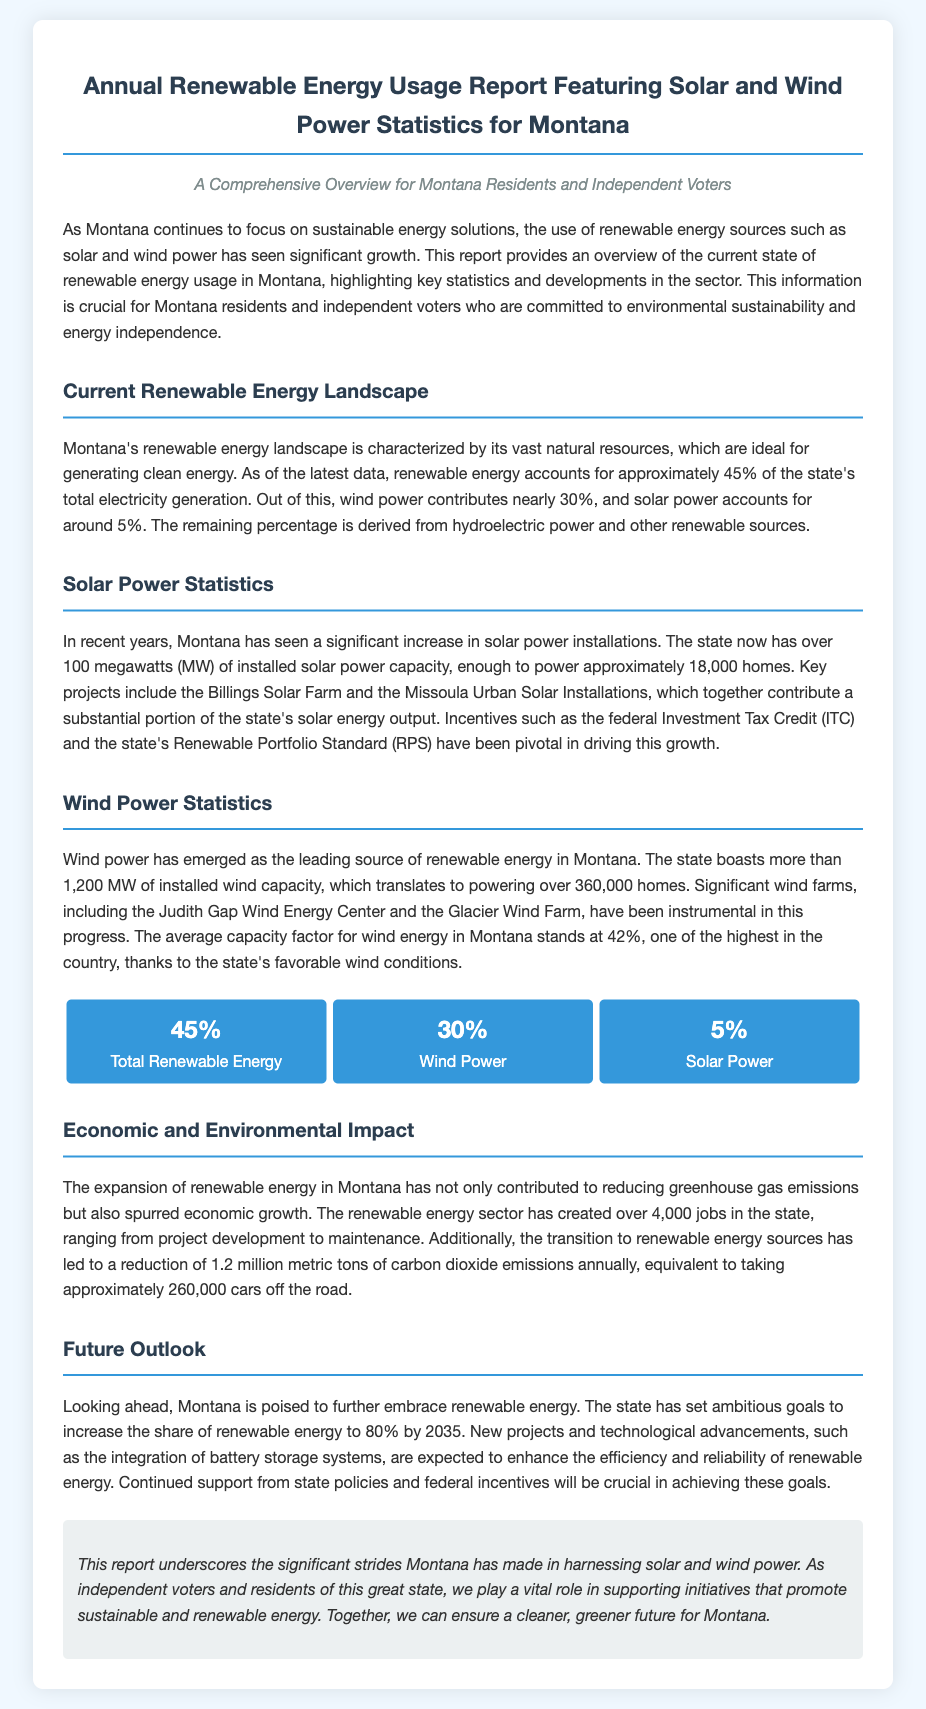what percentage of Montana's total electricity generation comes from renewable energy? The document states that renewable energy accounts for approximately 45% of the state's total electricity generation.
Answer: 45% how much installed solar power capacity does Montana have? According to the report, Montana has over 100 megawatts (MW) of installed solar power capacity.
Answer: over 100 megawatts how many homes can the installed wind capacity in Montana power? The document mentions that the installed wind capacity can power over 360,000 homes.
Answer: over 360,000 homes what is the average capacity factor for wind energy in Montana? The document states that the average capacity factor for wind energy in Montana stands at 42%.
Answer: 42% how many jobs has the renewable energy sector created in Montana? The report highlights that the renewable energy sector has created over 4,000 jobs in the state.
Answer: over 4,000 jobs what goal has Montana set for the share of renewable energy by 2035? The document states that Montana has set ambitious goals to increase the share of renewable energy to 80% by 2035.
Answer: 80% by 2035 what is the annual reduction of carbon dioxide emissions due to renewable energy in Montana? The report states that the transition to renewable energy sources has led to a reduction of 1.2 million metric tons of carbon dioxide emissions annually.
Answer: 1.2 million metric tons which wind farm is mentioned as significant in the report? The document mentions Judith Gap Wind Energy Center as a significant wind farm in Montana.
Answer: Judith Gap Wind Energy Center what is the contribution percentage of solar power in Montana's renewable energy? According to the report, solar power accounts for around 5% of Montana's renewable energy.
Answer: 5% 